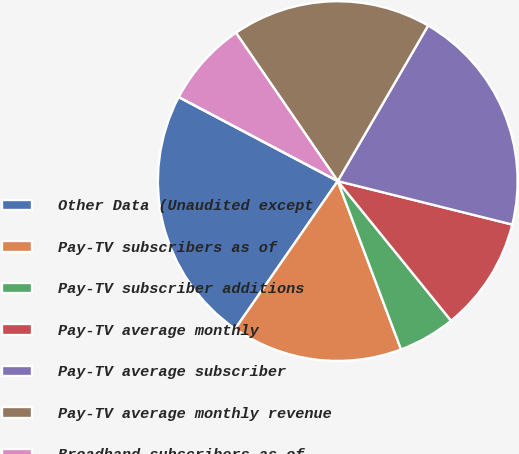<chart> <loc_0><loc_0><loc_500><loc_500><pie_chart><fcel>Other Data (Unaudited except<fcel>Pay-TV subscribers as of<fcel>Pay-TV subscriber additions<fcel>Pay-TV average monthly<fcel>Pay-TV average subscriber<fcel>Pay-TV average monthly revenue<fcel>Broadband subscribers as of<fcel>Broadband subscriber additions<nl><fcel>23.08%<fcel>15.38%<fcel>5.13%<fcel>10.26%<fcel>20.51%<fcel>17.95%<fcel>7.69%<fcel>0.0%<nl></chart> 